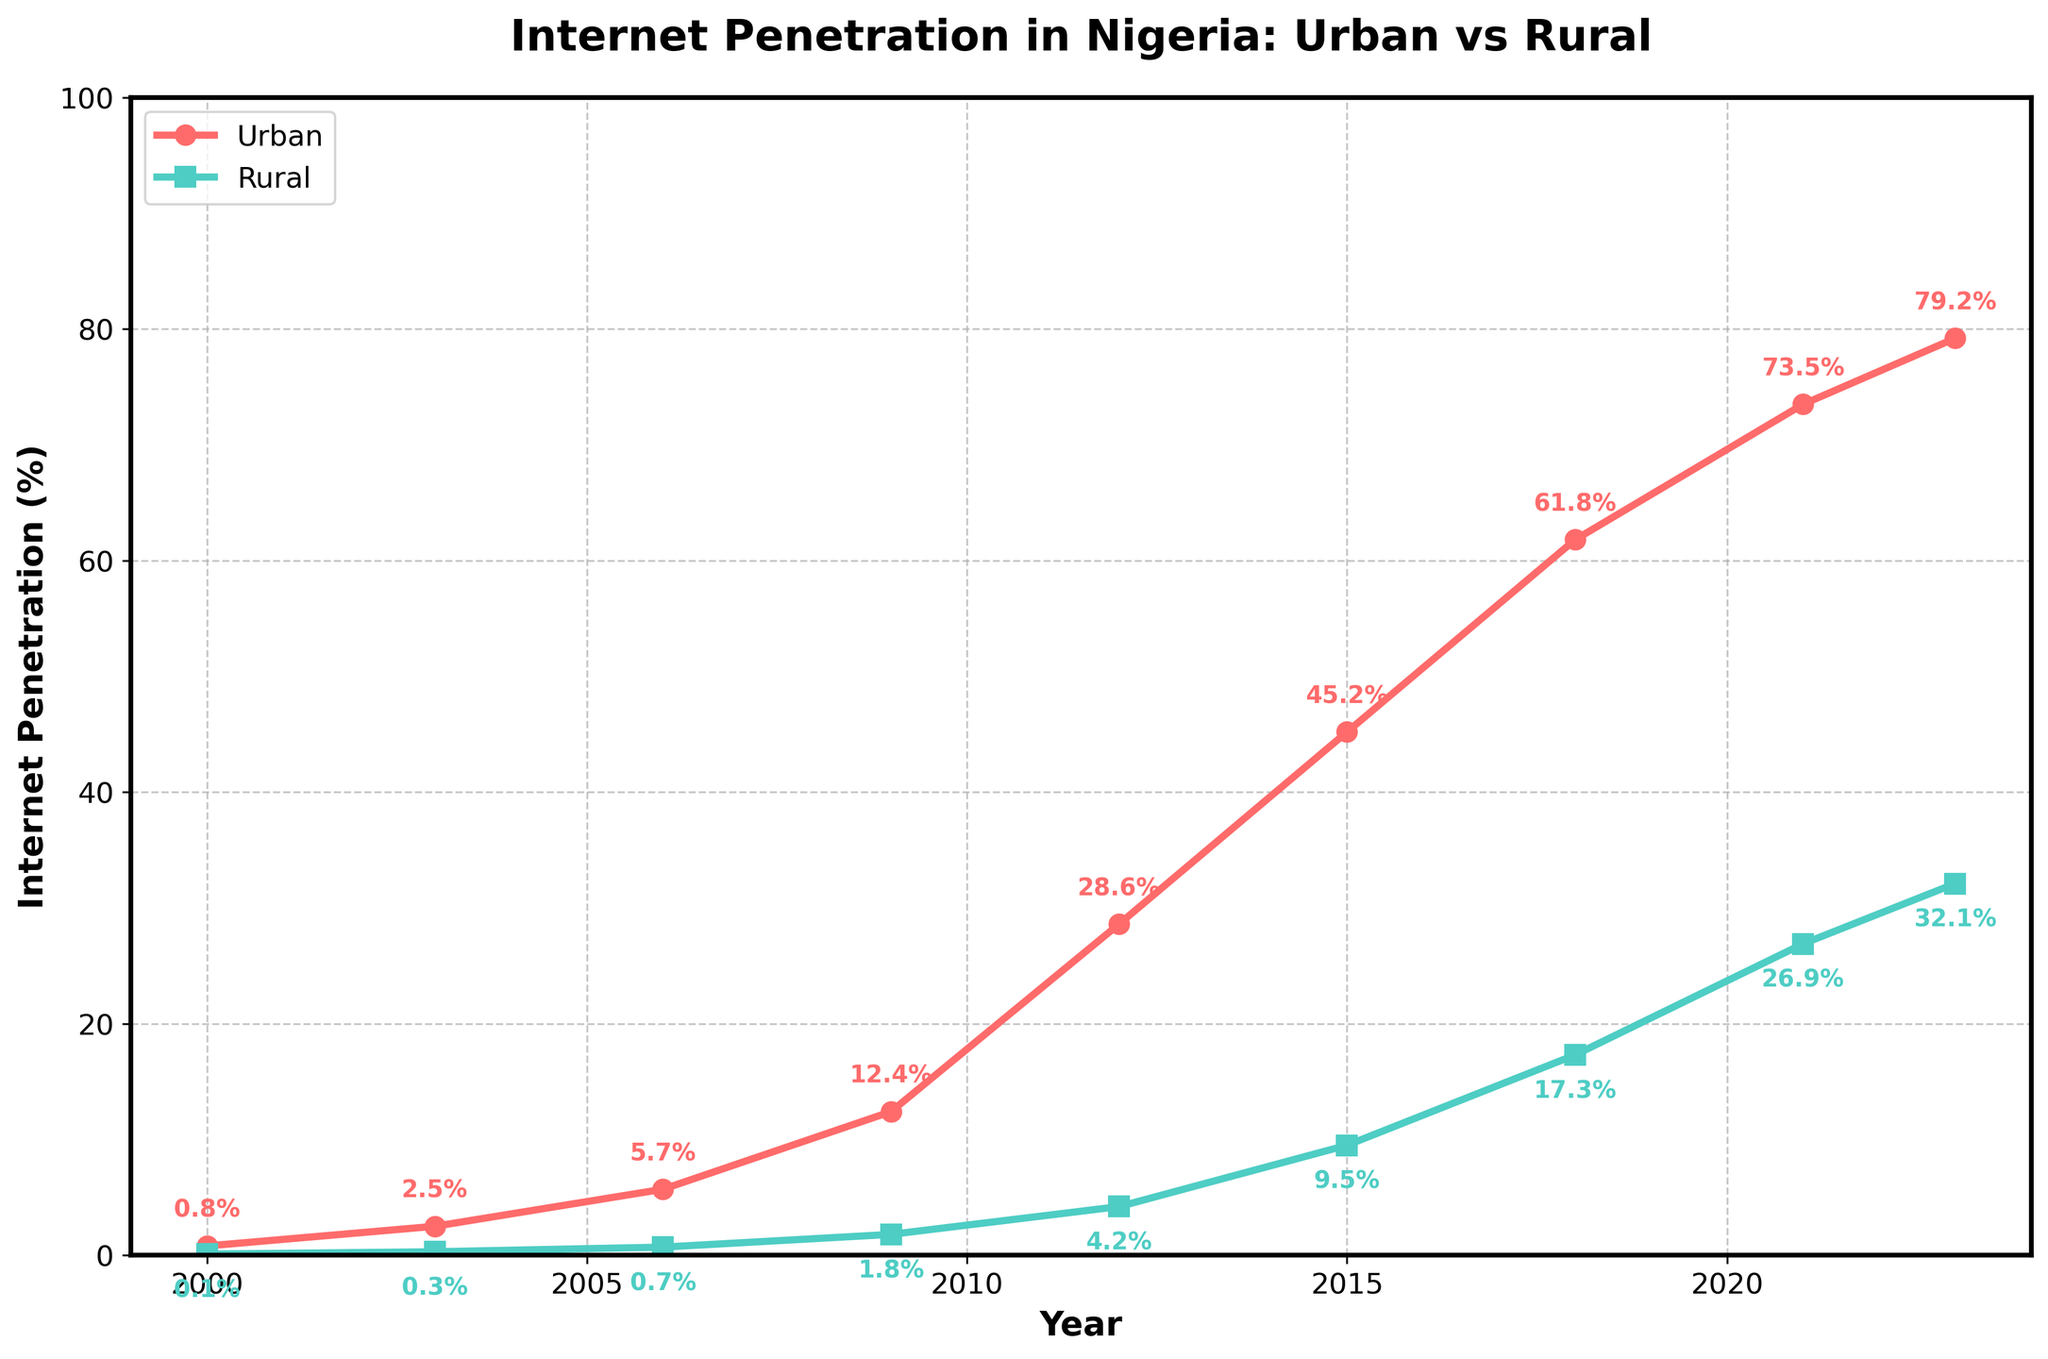What is the urban internet penetration rate in 2012? To find the urban internet penetration rate in 2012, locate the year 2012 on the x-axis and follow it up to where it intersects the urban (red) line. The marker shows 28.6%.
Answer: 28.6% How much did rural internet penetration grow between 2000 and 2023? Subtract the rural penetration rate in 2000 (0.1%) from the rate in 2023 (32.1%). This requires finding both values and calculating the difference: 32.1% - 0.1% = 32%.
Answer: 32% What is the difference between urban and rural internet penetration rates in 2021? Locate the penetration rates for urban (73.5%) and rural (26.9%) areas in 2021. Subtract the rural rate from the urban rate: 73.5% - 26.9% = 46.6%.
Answer: 46.6% During which year did urban internet penetration exceed 50%? Observe the urban line and find the year where it first crosses the 50% mark. This is between 2012 and 2015, specifically in 2015.
Answer: 2015 Which area had a higher internet penetration rate in 2006? Compare the internet penetration rates for urban (5.7%) and rural (0.7%) areas in 2006. Since 5.7% is greater than 0.7%, urban areas had a higher rate.
Answer: Urban Identify the year with the steepest increase in rural internet penetration. Observe the slope of the green (rural) line between each pair of years and identify the year with the steepest increase. The steepest increase appears between 2009 (1.8%) and 2012 (4.2%).
Answer: 2009-2012 What is the average urban internet penetration between 2000 and 2023? Add the urban internet penetration rates for all years: 0.8%, 2.5%, 5.7%, 12.4%, 28.6%, 45.2%, 61.8%, 73.5%, 79.2% and divide by the number of years (9). Average = (0.8 + 2.5 + 5.7 + 12.4 + 28.6 + 45.2 + 61.8 + 73.5 + 79.2) / 9 ≈ 34%.
Answer: ~34% By how much did the urban internet penetration rate exceed the rural penetration rate on average over the years? First, find the difference between urban and rural penetration rates each year, then sum these differences and divide by the number of years: ((0.8-0.1) + (2.5-0.3) + (5.7-0.7) + (12.4-1.8) + (28.6-4.2) + (45.2-9.5) + (61.8-17.3) + (73.5-26.9) + (79.2-32.1)) / 9 ≈ 37%.
Answer: ~37% Between which consecutive years did urban internet penetration see the highest growth? Calculate the differences between consecutive years for the red (urban) line: (2.5-0.8), (5.7-2.5), (12.4-5.7), (28.6-12.4), (45.2-28.6), (61.8-45.2), (73.5-61.8), and (79.2-73.5). The highest growth is between 2009 (12.4%) and 2012 (28.6%), with a rise of 16.2%.
Answer: 2009-2012 